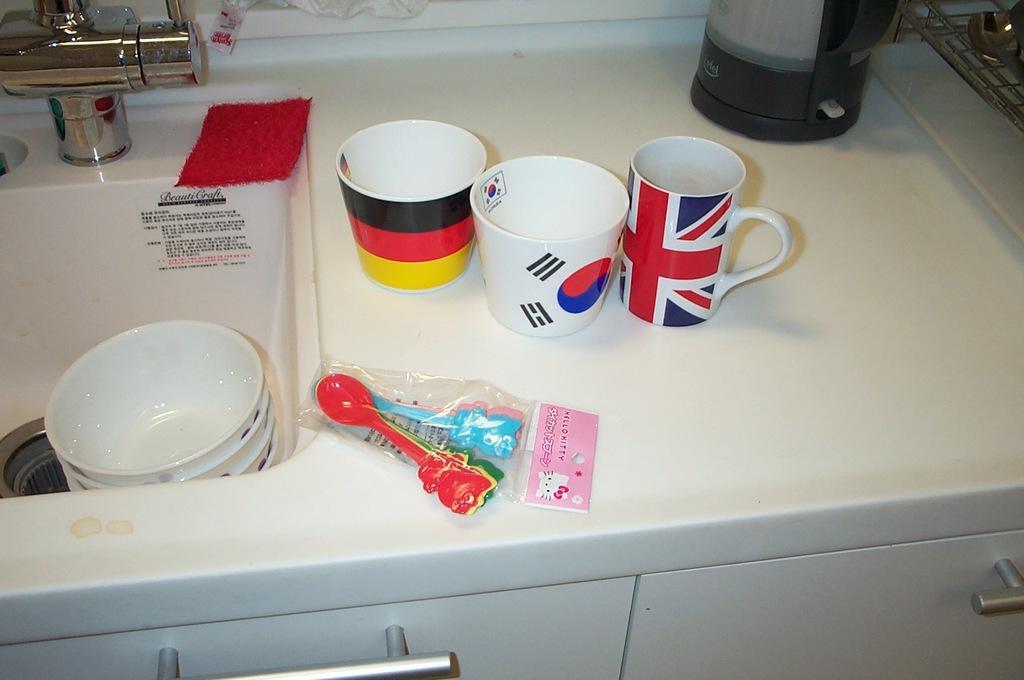In one or two sentences, can you explain what this image depicts? In this image we can see a sink here and tap. In the sink we can find 4 bowls. And there is a scrubber here. Behind the sink it is like table on which 3 tea cups are present and also some spoons are present. These spoons are plastic. That is it. 